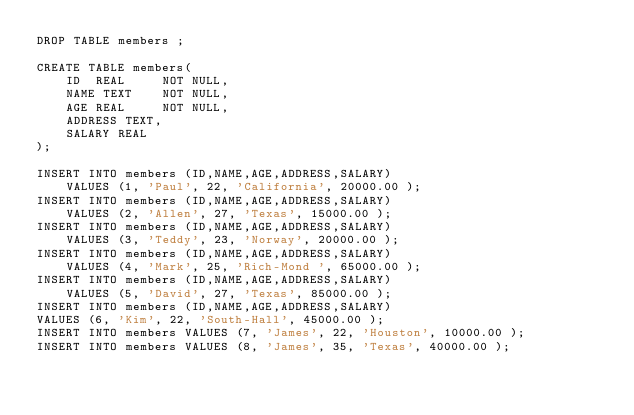<code> <loc_0><loc_0><loc_500><loc_500><_SQL_>DROP TABLE members ;

CREATE TABLE members(
    ID  REAL     NOT NULL,
   	NAME TEXT    NOT NULL,
   	AGE REAL     NOT NULL,
   	ADDRESS TEXT,
   	SALARY REAL
);

INSERT INTO members (ID,NAME,AGE,ADDRESS,SALARY)
		VALUES (1, 'Paul', 22, 'California', 20000.00 );
INSERT INTO members (ID,NAME,AGE,ADDRESS,SALARY)
		VALUES (2, 'Allen', 27, 'Texas', 15000.00 );
INSERT INTO members (ID,NAME,AGE,ADDRESS,SALARY)
		VALUES (3, 'Teddy', 23, 'Norway', 20000.00 );
INSERT INTO members (ID,NAME,AGE,ADDRESS,SALARY)
		VALUES (4, 'Mark', 25, 'Rich-Mond ', 65000.00 );
INSERT INTO members (ID,NAME,AGE,ADDRESS,SALARY)
		VALUES (5, 'David', 27, 'Texas', 85000.00 );
INSERT INTO members (ID,NAME,AGE,ADDRESS,SALARY)
VALUES (6, 'Kim', 22, 'South-Hall', 45000.00 );
INSERT INTO members VALUES (7, 'James', 22, 'Houston', 10000.00 );
INSERT INTO members VALUES (8, 'James', 35, 'Texas', 40000.00 );
</code> 